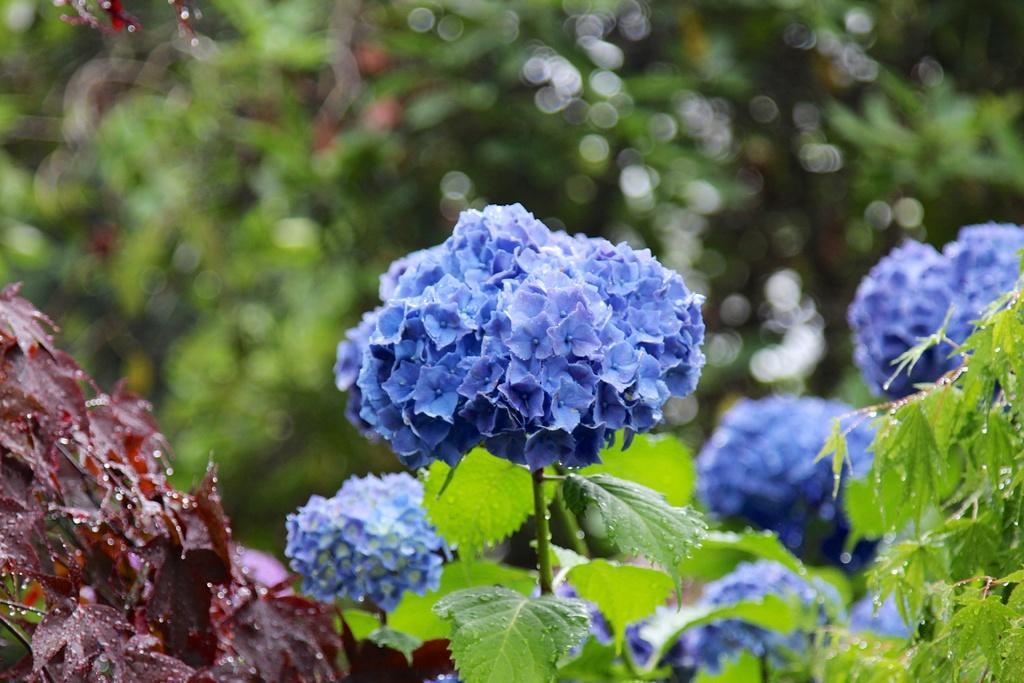How would you summarize this image in a sentence or two? In this image we can see the plants with flowers and the background is blurred. 